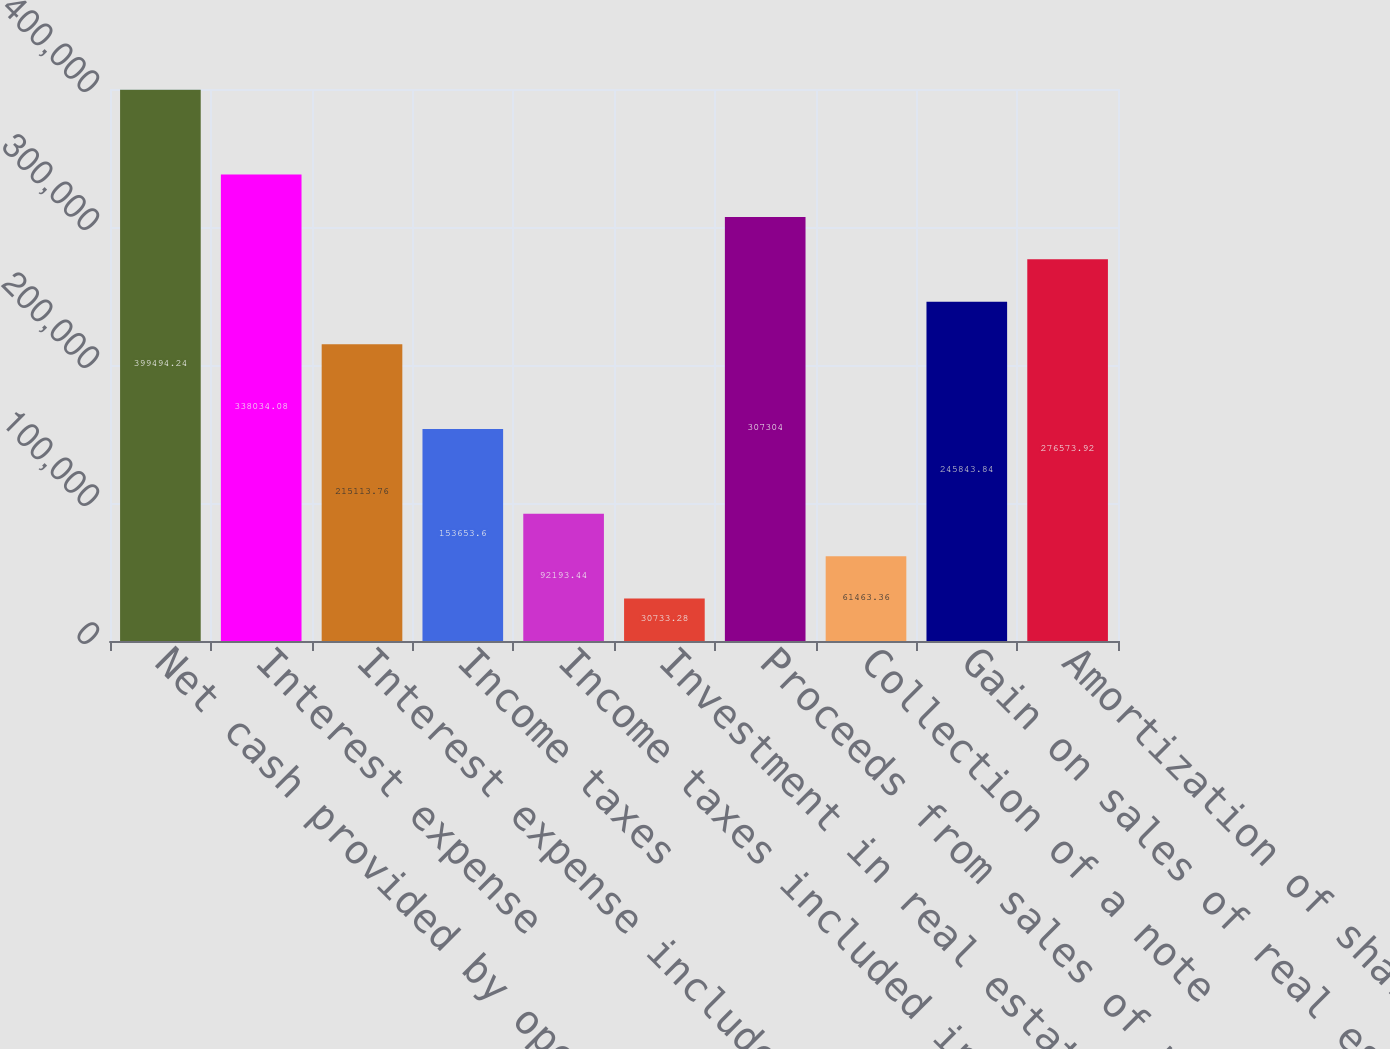Convert chart to OTSL. <chart><loc_0><loc_0><loc_500><loc_500><bar_chart><fcel>Net cash provided by operating<fcel>Interest expense<fcel>Interest expense included in<fcel>Income taxes<fcel>Income taxes included in<fcel>Investment in real estate<fcel>Proceeds from sales of real<fcel>Collection of a note<fcel>Gain on sales of real estate<fcel>Amortization of share-based<nl><fcel>399494<fcel>338034<fcel>215114<fcel>153654<fcel>92193.4<fcel>30733.3<fcel>307304<fcel>61463.4<fcel>245844<fcel>276574<nl></chart> 